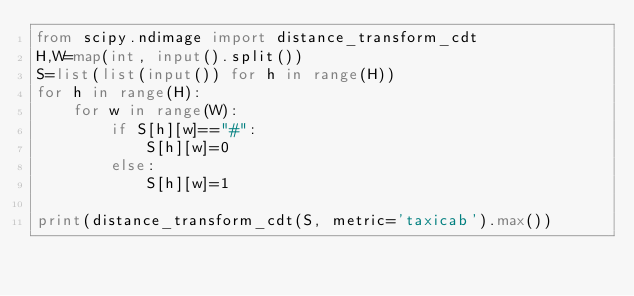<code> <loc_0><loc_0><loc_500><loc_500><_Python_>from scipy.ndimage import distance_transform_cdt
H,W=map(int, input().split())
S=list(list(input()) for h in range(H))
for h in range(H):
    for w in range(W):
        if S[h][w]=="#":
            S[h][w]=0
        else:
            S[h][w]=1

print(distance_transform_cdt(S, metric='taxicab').max())
</code> 